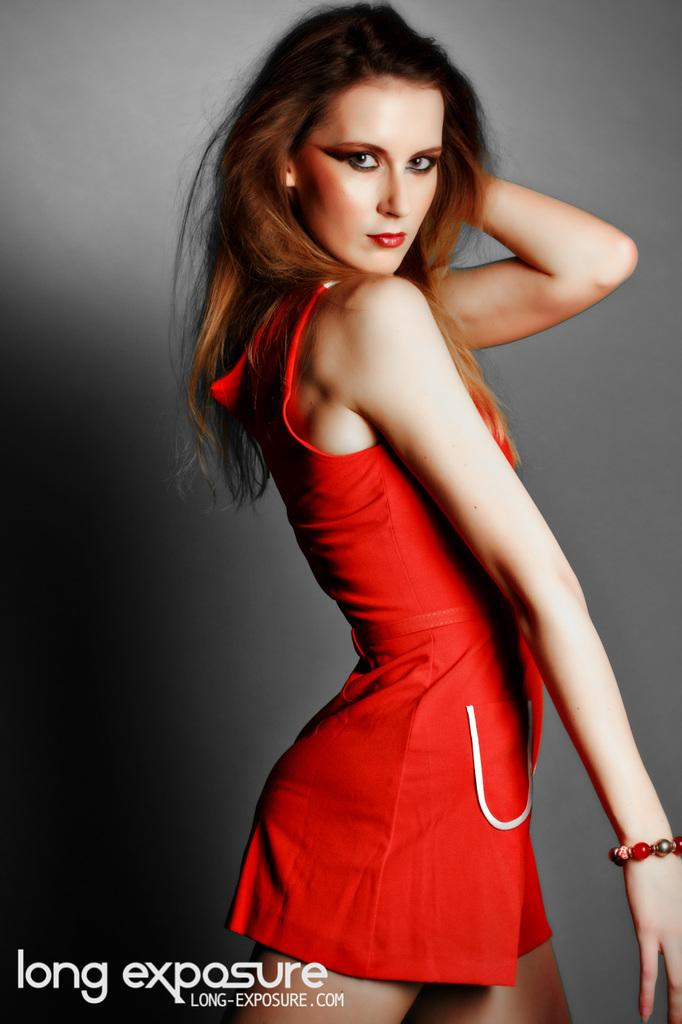<image>
Summarize the visual content of the image. A website for long exposure can be seen in an ad that also features a woman in a red dress. 